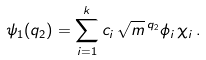<formula> <loc_0><loc_0><loc_500><loc_500>\psi _ { 1 } ( q _ { 2 } ) = \sum _ { i = 1 } ^ { k } c _ { i } \, \sqrt { m } \, ^ { q _ { 2 } } { \phi _ { i } } \, \chi _ { i } \, .</formula> 